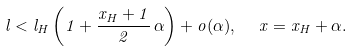Convert formula to latex. <formula><loc_0><loc_0><loc_500><loc_500>l < l _ { H } \left ( 1 + \frac { x _ { H } + 1 } { 2 } \, \alpha \right ) + o ( \alpha ) , \ \ x = x _ { H } + \alpha .</formula> 